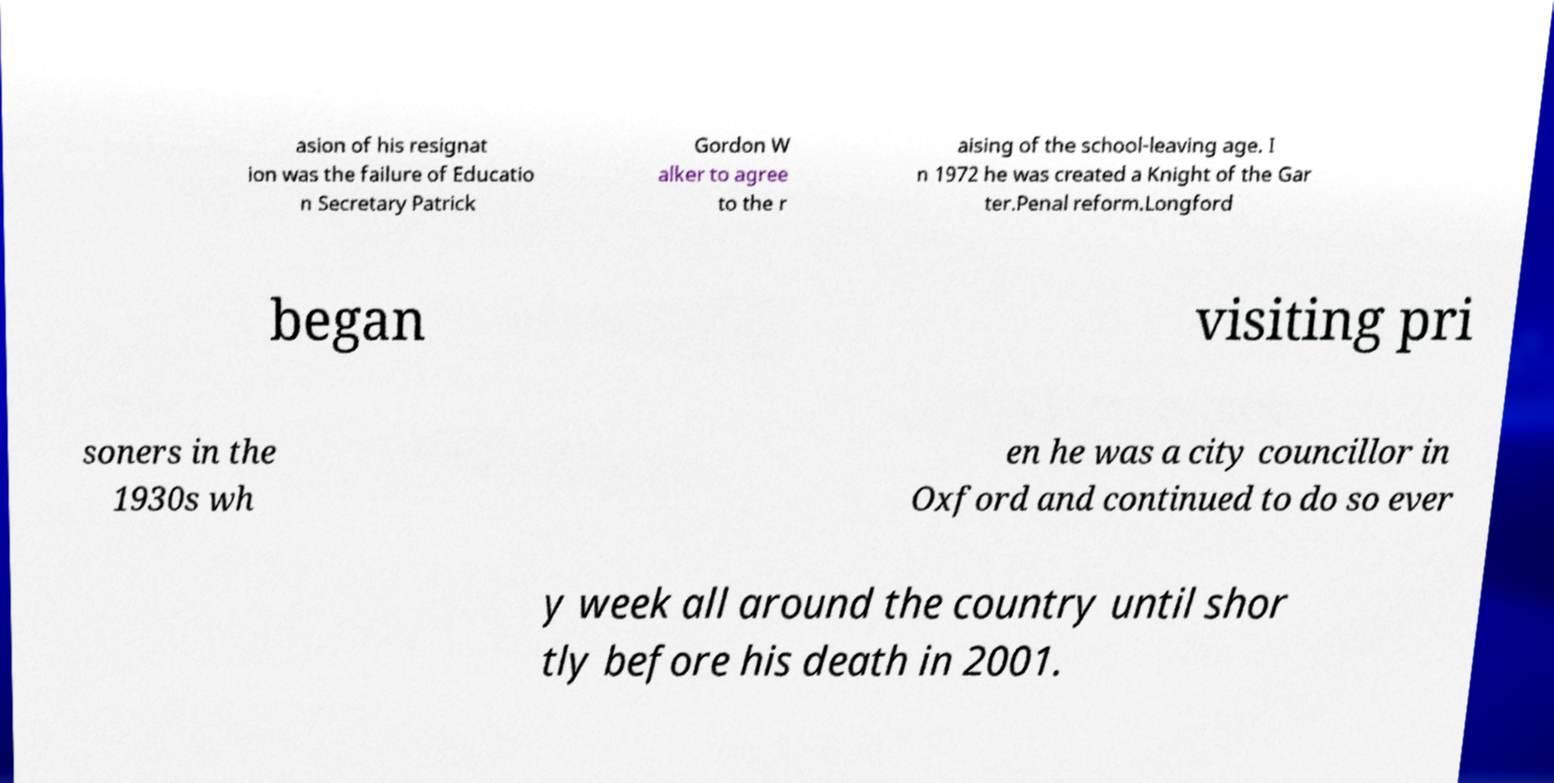I need the written content from this picture converted into text. Can you do that? asion of his resignat ion was the failure of Educatio n Secretary Patrick Gordon W alker to agree to the r aising of the school-leaving age. I n 1972 he was created a Knight of the Gar ter.Penal reform.Longford began visiting pri soners in the 1930s wh en he was a city councillor in Oxford and continued to do so ever y week all around the country until shor tly before his death in 2001. 